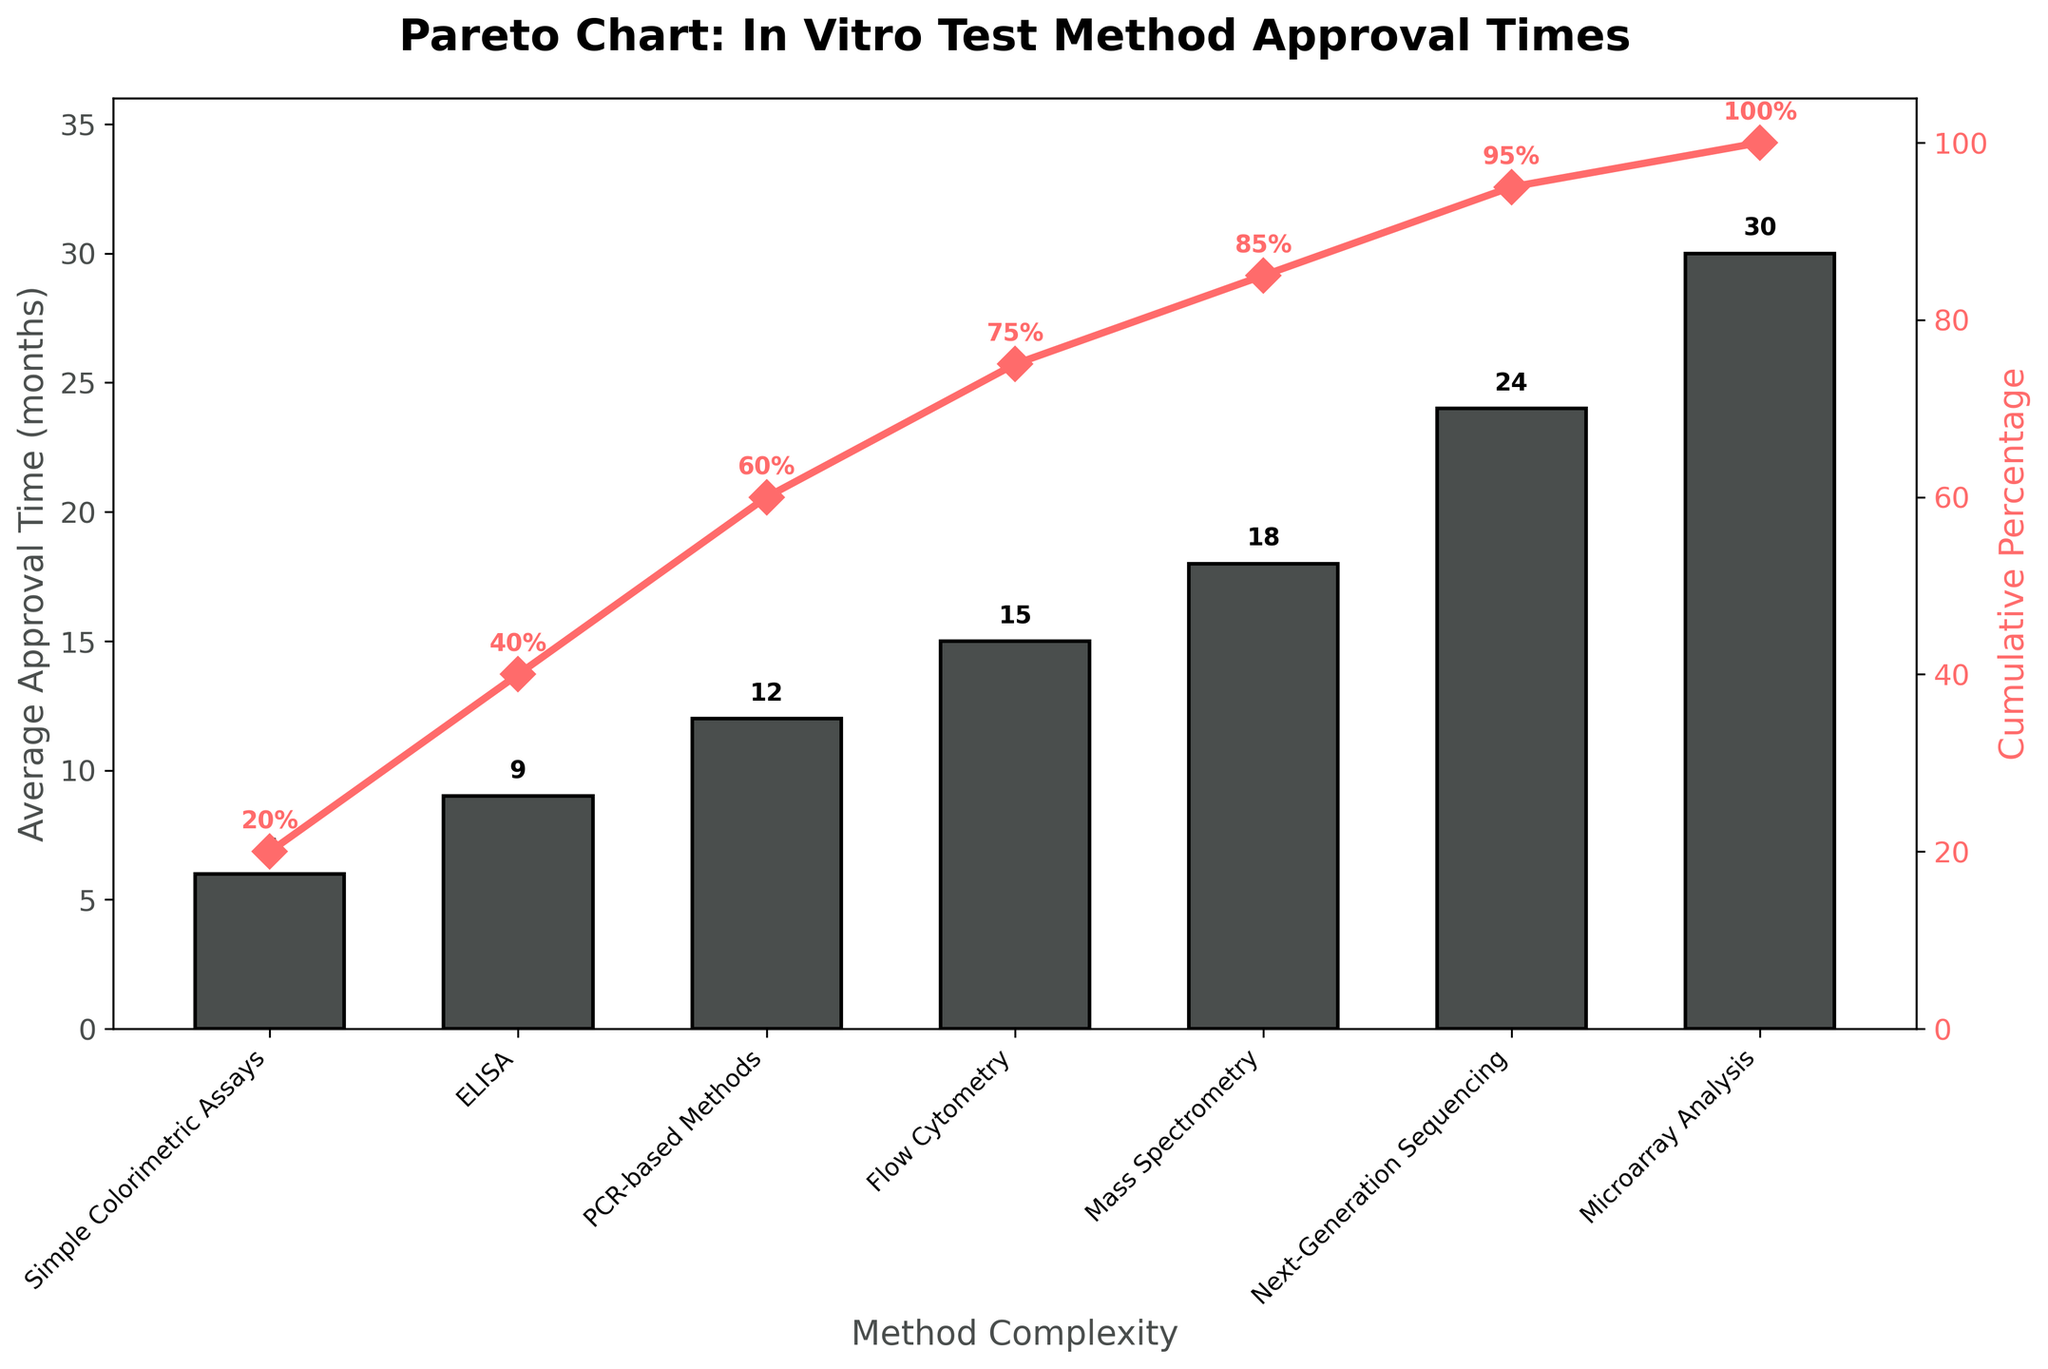What is the title of the figure? The title is located at the top of the chart. It reads "Pareto Chart: In Vitro Test Method Approval Times".
Answer: Pareto Chart: In Vitro Test Method Approval Times How many different method complexities are listed in the figure? The method complexities are represented by the x-axis labels. By counting them, we see there are seven different method complexities.
Answer: Seven Which method complexity has the longest average approval time? By looking at the height of the bars, the longest one represents "Microarray Analysis" with 30 months.
Answer: Microarray Analysis What is the shortest average approval time, and which method does it correspond to? The shortest bar corresponds to "Simple Colorimetric Assays" with an average approval time of 6 months.
Answer: 6 months, Simple Colorimetric Assays What cumulative percentage is reached after the fourth method complexity? The cumulative percentage after the fourth method, which is "Flow Cytometry", is 75%. This is indicated by both the cumulative percentage line and text labels.
Answer: 75% How much longer does it take on average to approve "Next-Generation Sequencing" compared to "PCR-based Methods"? The average approval times are 24 months for "Next-Generation Sequencing" and 12 months for "PCR-based Methods". The difference is 24 - 12 = 12 months.
Answer: 12 months What is the cumulative percentage difference between "Flow Cytometry" and "Next-Generation Sequencing"? The cumulative percentages are 75% for "Flow Cytometry" and 95% for "Next-Generation Sequencing". The difference is 95% - 75% = 20%.
Answer: 20% If you combined the average approval times of "ELISA" and "Mass Spectrometry", what would be the total time? The average approval times are 9 months for "ELISA" and 18 months for "Mass Spectrometry". The combined total is 9 + 18 = 27 months.
Answer: 27 months Which method complexities fall within the 60% cumulative percentage mark? From the cumulative percentage line, "Simple Colorimetric Assays", "ELISA", and "PCR-based Methods" are within or at the 60% cumulative percentage mark.
Answer: Simple Colorimetric Assays, ELISA, PCR-based Methods 